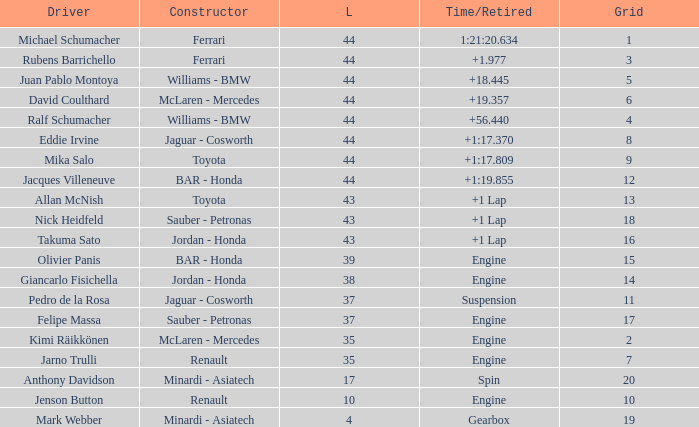What was the time of the driver on grid 3? 1.977. 